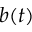Convert formula to latex. <formula><loc_0><loc_0><loc_500><loc_500>b ( t )</formula> 